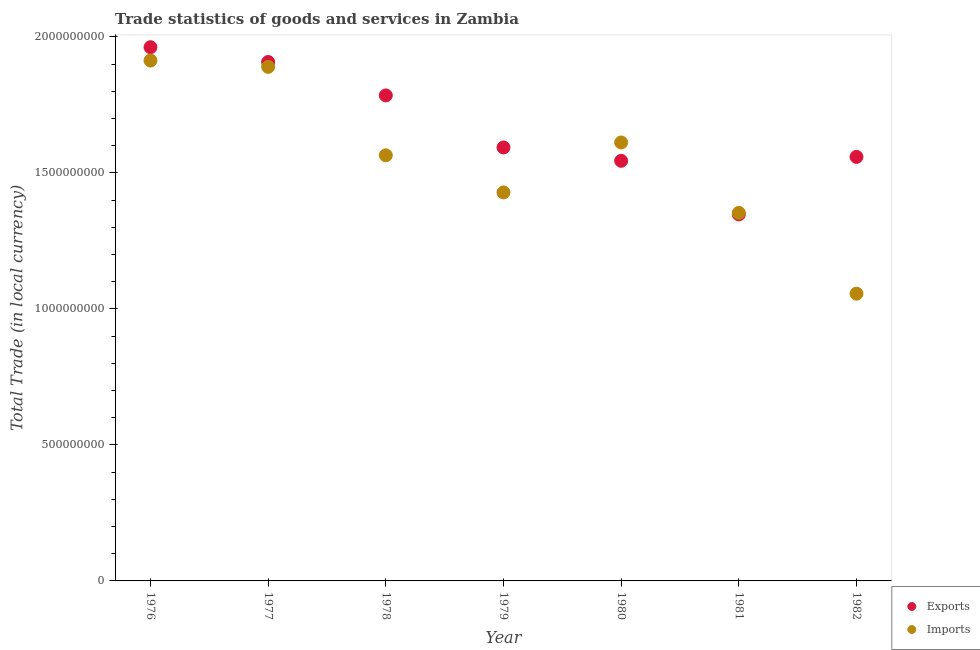Is the number of dotlines equal to the number of legend labels?
Offer a very short reply. Yes. What is the export of goods and services in 1981?
Give a very brief answer. 1.35e+09. Across all years, what is the maximum imports of goods and services?
Provide a succinct answer. 1.91e+09. Across all years, what is the minimum imports of goods and services?
Ensure brevity in your answer.  1.06e+09. In which year was the imports of goods and services maximum?
Your answer should be compact. 1976. In which year was the export of goods and services minimum?
Keep it short and to the point. 1981. What is the total export of goods and services in the graph?
Your answer should be compact. 1.17e+1. What is the difference between the imports of goods and services in 1978 and that in 1981?
Offer a terse response. 2.11e+08. What is the difference between the export of goods and services in 1982 and the imports of goods and services in 1977?
Your response must be concise. -3.31e+08. What is the average export of goods and services per year?
Ensure brevity in your answer.  1.67e+09. In the year 1981, what is the difference between the export of goods and services and imports of goods and services?
Your response must be concise. -5.75e+06. What is the ratio of the export of goods and services in 1980 to that in 1982?
Offer a terse response. 0.99. What is the difference between the highest and the second highest imports of goods and services?
Provide a succinct answer. 2.31e+07. What is the difference between the highest and the lowest imports of goods and services?
Ensure brevity in your answer.  8.57e+08. In how many years, is the export of goods and services greater than the average export of goods and services taken over all years?
Ensure brevity in your answer.  3. Is the sum of the imports of goods and services in 1980 and 1981 greater than the maximum export of goods and services across all years?
Make the answer very short. Yes. Does the imports of goods and services monotonically increase over the years?
Your answer should be compact. No. How many dotlines are there?
Keep it short and to the point. 2. How many years are there in the graph?
Your answer should be compact. 7. Are the values on the major ticks of Y-axis written in scientific E-notation?
Provide a succinct answer. No. Does the graph contain any zero values?
Offer a very short reply. No. Does the graph contain grids?
Offer a very short reply. No. How are the legend labels stacked?
Your answer should be compact. Vertical. What is the title of the graph?
Provide a succinct answer. Trade statistics of goods and services in Zambia. What is the label or title of the Y-axis?
Make the answer very short. Total Trade (in local currency). What is the Total Trade (in local currency) in Exports in 1976?
Make the answer very short. 1.96e+09. What is the Total Trade (in local currency) in Imports in 1976?
Ensure brevity in your answer.  1.91e+09. What is the Total Trade (in local currency) in Exports in 1977?
Ensure brevity in your answer.  1.91e+09. What is the Total Trade (in local currency) of Imports in 1977?
Your answer should be very brief. 1.89e+09. What is the Total Trade (in local currency) of Exports in 1978?
Keep it short and to the point. 1.78e+09. What is the Total Trade (in local currency) in Imports in 1978?
Offer a very short reply. 1.56e+09. What is the Total Trade (in local currency) in Exports in 1979?
Your response must be concise. 1.59e+09. What is the Total Trade (in local currency) in Imports in 1979?
Offer a very short reply. 1.43e+09. What is the Total Trade (in local currency) in Exports in 1980?
Your answer should be compact. 1.54e+09. What is the Total Trade (in local currency) in Imports in 1980?
Provide a short and direct response. 1.61e+09. What is the Total Trade (in local currency) in Exports in 1981?
Provide a succinct answer. 1.35e+09. What is the Total Trade (in local currency) in Imports in 1981?
Provide a succinct answer. 1.35e+09. What is the Total Trade (in local currency) in Exports in 1982?
Offer a very short reply. 1.56e+09. What is the Total Trade (in local currency) in Imports in 1982?
Ensure brevity in your answer.  1.06e+09. Across all years, what is the maximum Total Trade (in local currency) in Exports?
Your response must be concise. 1.96e+09. Across all years, what is the maximum Total Trade (in local currency) in Imports?
Provide a succinct answer. 1.91e+09. Across all years, what is the minimum Total Trade (in local currency) in Exports?
Make the answer very short. 1.35e+09. Across all years, what is the minimum Total Trade (in local currency) in Imports?
Ensure brevity in your answer.  1.06e+09. What is the total Total Trade (in local currency) of Exports in the graph?
Give a very brief answer. 1.17e+1. What is the total Total Trade (in local currency) of Imports in the graph?
Your answer should be very brief. 1.08e+1. What is the difference between the Total Trade (in local currency) in Exports in 1976 and that in 1977?
Offer a terse response. 5.44e+07. What is the difference between the Total Trade (in local currency) in Imports in 1976 and that in 1977?
Provide a succinct answer. 2.31e+07. What is the difference between the Total Trade (in local currency) of Exports in 1976 and that in 1978?
Make the answer very short. 1.77e+08. What is the difference between the Total Trade (in local currency) in Imports in 1976 and that in 1978?
Offer a very short reply. 3.48e+08. What is the difference between the Total Trade (in local currency) in Exports in 1976 and that in 1979?
Keep it short and to the point. 3.69e+08. What is the difference between the Total Trade (in local currency) in Imports in 1976 and that in 1979?
Give a very brief answer. 4.85e+08. What is the difference between the Total Trade (in local currency) of Exports in 1976 and that in 1980?
Your answer should be very brief. 4.18e+08. What is the difference between the Total Trade (in local currency) of Imports in 1976 and that in 1980?
Your answer should be very brief. 3.01e+08. What is the difference between the Total Trade (in local currency) of Exports in 1976 and that in 1981?
Your response must be concise. 6.15e+08. What is the difference between the Total Trade (in local currency) of Imports in 1976 and that in 1981?
Keep it short and to the point. 5.60e+08. What is the difference between the Total Trade (in local currency) of Exports in 1976 and that in 1982?
Keep it short and to the point. 4.03e+08. What is the difference between the Total Trade (in local currency) of Imports in 1976 and that in 1982?
Your answer should be very brief. 8.57e+08. What is the difference between the Total Trade (in local currency) of Exports in 1977 and that in 1978?
Ensure brevity in your answer.  1.23e+08. What is the difference between the Total Trade (in local currency) in Imports in 1977 and that in 1978?
Keep it short and to the point. 3.25e+08. What is the difference between the Total Trade (in local currency) in Exports in 1977 and that in 1979?
Make the answer very short. 3.14e+08. What is the difference between the Total Trade (in local currency) in Imports in 1977 and that in 1979?
Make the answer very short. 4.61e+08. What is the difference between the Total Trade (in local currency) of Exports in 1977 and that in 1980?
Keep it short and to the point. 3.63e+08. What is the difference between the Total Trade (in local currency) of Imports in 1977 and that in 1980?
Ensure brevity in your answer.  2.78e+08. What is the difference between the Total Trade (in local currency) in Exports in 1977 and that in 1981?
Your answer should be very brief. 5.60e+08. What is the difference between the Total Trade (in local currency) of Imports in 1977 and that in 1981?
Ensure brevity in your answer.  5.37e+08. What is the difference between the Total Trade (in local currency) of Exports in 1977 and that in 1982?
Keep it short and to the point. 3.49e+08. What is the difference between the Total Trade (in local currency) in Imports in 1977 and that in 1982?
Provide a short and direct response. 8.34e+08. What is the difference between the Total Trade (in local currency) of Exports in 1978 and that in 1979?
Your answer should be very brief. 1.91e+08. What is the difference between the Total Trade (in local currency) of Imports in 1978 and that in 1979?
Your response must be concise. 1.36e+08. What is the difference between the Total Trade (in local currency) of Exports in 1978 and that in 1980?
Make the answer very short. 2.40e+08. What is the difference between the Total Trade (in local currency) of Imports in 1978 and that in 1980?
Keep it short and to the point. -4.72e+07. What is the difference between the Total Trade (in local currency) of Exports in 1978 and that in 1981?
Provide a succinct answer. 4.37e+08. What is the difference between the Total Trade (in local currency) in Imports in 1978 and that in 1981?
Keep it short and to the point. 2.11e+08. What is the difference between the Total Trade (in local currency) in Exports in 1978 and that in 1982?
Your answer should be very brief. 2.26e+08. What is the difference between the Total Trade (in local currency) in Imports in 1978 and that in 1982?
Give a very brief answer. 5.09e+08. What is the difference between the Total Trade (in local currency) in Exports in 1979 and that in 1980?
Keep it short and to the point. 4.91e+07. What is the difference between the Total Trade (in local currency) of Imports in 1979 and that in 1980?
Keep it short and to the point. -1.84e+08. What is the difference between the Total Trade (in local currency) of Exports in 1979 and that in 1981?
Your response must be concise. 2.46e+08. What is the difference between the Total Trade (in local currency) in Imports in 1979 and that in 1981?
Offer a terse response. 7.51e+07. What is the difference between the Total Trade (in local currency) in Exports in 1979 and that in 1982?
Your answer should be compact. 3.47e+07. What is the difference between the Total Trade (in local currency) in Imports in 1979 and that in 1982?
Your answer should be very brief. 3.72e+08. What is the difference between the Total Trade (in local currency) in Exports in 1980 and that in 1981?
Offer a very short reply. 1.97e+08. What is the difference between the Total Trade (in local currency) in Imports in 1980 and that in 1981?
Ensure brevity in your answer.  2.59e+08. What is the difference between the Total Trade (in local currency) of Exports in 1980 and that in 1982?
Your answer should be compact. -1.44e+07. What is the difference between the Total Trade (in local currency) in Imports in 1980 and that in 1982?
Make the answer very short. 5.56e+08. What is the difference between the Total Trade (in local currency) in Exports in 1981 and that in 1982?
Offer a very short reply. -2.11e+08. What is the difference between the Total Trade (in local currency) in Imports in 1981 and that in 1982?
Your answer should be compact. 2.97e+08. What is the difference between the Total Trade (in local currency) of Exports in 1976 and the Total Trade (in local currency) of Imports in 1977?
Offer a very short reply. 7.23e+07. What is the difference between the Total Trade (in local currency) of Exports in 1976 and the Total Trade (in local currency) of Imports in 1978?
Ensure brevity in your answer.  3.97e+08. What is the difference between the Total Trade (in local currency) in Exports in 1976 and the Total Trade (in local currency) in Imports in 1979?
Provide a succinct answer. 5.34e+08. What is the difference between the Total Trade (in local currency) in Exports in 1976 and the Total Trade (in local currency) in Imports in 1980?
Provide a succinct answer. 3.50e+08. What is the difference between the Total Trade (in local currency) of Exports in 1976 and the Total Trade (in local currency) of Imports in 1981?
Keep it short and to the point. 6.09e+08. What is the difference between the Total Trade (in local currency) in Exports in 1976 and the Total Trade (in local currency) in Imports in 1982?
Keep it short and to the point. 9.06e+08. What is the difference between the Total Trade (in local currency) in Exports in 1977 and the Total Trade (in local currency) in Imports in 1978?
Offer a terse response. 3.43e+08. What is the difference between the Total Trade (in local currency) in Exports in 1977 and the Total Trade (in local currency) in Imports in 1979?
Give a very brief answer. 4.79e+08. What is the difference between the Total Trade (in local currency) of Exports in 1977 and the Total Trade (in local currency) of Imports in 1980?
Your answer should be compact. 2.96e+08. What is the difference between the Total Trade (in local currency) of Exports in 1977 and the Total Trade (in local currency) of Imports in 1981?
Your answer should be compact. 5.54e+08. What is the difference between the Total Trade (in local currency) in Exports in 1977 and the Total Trade (in local currency) in Imports in 1982?
Offer a very short reply. 8.52e+08. What is the difference between the Total Trade (in local currency) in Exports in 1978 and the Total Trade (in local currency) in Imports in 1979?
Ensure brevity in your answer.  3.57e+08. What is the difference between the Total Trade (in local currency) of Exports in 1978 and the Total Trade (in local currency) of Imports in 1980?
Ensure brevity in your answer.  1.73e+08. What is the difference between the Total Trade (in local currency) in Exports in 1978 and the Total Trade (in local currency) in Imports in 1981?
Offer a very short reply. 4.32e+08. What is the difference between the Total Trade (in local currency) in Exports in 1978 and the Total Trade (in local currency) in Imports in 1982?
Offer a terse response. 7.29e+08. What is the difference between the Total Trade (in local currency) in Exports in 1979 and the Total Trade (in local currency) in Imports in 1980?
Offer a very short reply. -1.84e+07. What is the difference between the Total Trade (in local currency) in Exports in 1979 and the Total Trade (in local currency) in Imports in 1981?
Offer a terse response. 2.40e+08. What is the difference between the Total Trade (in local currency) of Exports in 1979 and the Total Trade (in local currency) of Imports in 1982?
Give a very brief answer. 5.37e+08. What is the difference between the Total Trade (in local currency) of Exports in 1980 and the Total Trade (in local currency) of Imports in 1981?
Make the answer very short. 1.91e+08. What is the difference between the Total Trade (in local currency) of Exports in 1980 and the Total Trade (in local currency) of Imports in 1982?
Offer a very short reply. 4.88e+08. What is the difference between the Total Trade (in local currency) in Exports in 1981 and the Total Trade (in local currency) in Imports in 1982?
Keep it short and to the point. 2.91e+08. What is the average Total Trade (in local currency) in Exports per year?
Offer a very short reply. 1.67e+09. What is the average Total Trade (in local currency) in Imports per year?
Your answer should be very brief. 1.55e+09. In the year 1976, what is the difference between the Total Trade (in local currency) in Exports and Total Trade (in local currency) in Imports?
Keep it short and to the point. 4.91e+07. In the year 1977, what is the difference between the Total Trade (in local currency) in Exports and Total Trade (in local currency) in Imports?
Your answer should be very brief. 1.79e+07. In the year 1978, what is the difference between the Total Trade (in local currency) of Exports and Total Trade (in local currency) of Imports?
Make the answer very short. 2.20e+08. In the year 1979, what is the difference between the Total Trade (in local currency) in Exports and Total Trade (in local currency) in Imports?
Your answer should be very brief. 1.65e+08. In the year 1980, what is the difference between the Total Trade (in local currency) in Exports and Total Trade (in local currency) in Imports?
Your answer should be compact. -6.74e+07. In the year 1981, what is the difference between the Total Trade (in local currency) of Exports and Total Trade (in local currency) of Imports?
Your answer should be very brief. -5.75e+06. In the year 1982, what is the difference between the Total Trade (in local currency) of Exports and Total Trade (in local currency) of Imports?
Your answer should be very brief. 5.03e+08. What is the ratio of the Total Trade (in local currency) of Exports in 1976 to that in 1977?
Give a very brief answer. 1.03. What is the ratio of the Total Trade (in local currency) in Imports in 1976 to that in 1977?
Your response must be concise. 1.01. What is the ratio of the Total Trade (in local currency) of Exports in 1976 to that in 1978?
Your response must be concise. 1.1. What is the ratio of the Total Trade (in local currency) of Imports in 1976 to that in 1978?
Keep it short and to the point. 1.22. What is the ratio of the Total Trade (in local currency) in Exports in 1976 to that in 1979?
Provide a succinct answer. 1.23. What is the ratio of the Total Trade (in local currency) in Imports in 1976 to that in 1979?
Give a very brief answer. 1.34. What is the ratio of the Total Trade (in local currency) in Exports in 1976 to that in 1980?
Your answer should be compact. 1.27. What is the ratio of the Total Trade (in local currency) of Imports in 1976 to that in 1980?
Your answer should be compact. 1.19. What is the ratio of the Total Trade (in local currency) in Exports in 1976 to that in 1981?
Offer a very short reply. 1.46. What is the ratio of the Total Trade (in local currency) in Imports in 1976 to that in 1981?
Your answer should be compact. 1.41. What is the ratio of the Total Trade (in local currency) of Exports in 1976 to that in 1982?
Keep it short and to the point. 1.26. What is the ratio of the Total Trade (in local currency) of Imports in 1976 to that in 1982?
Make the answer very short. 1.81. What is the ratio of the Total Trade (in local currency) in Exports in 1977 to that in 1978?
Give a very brief answer. 1.07. What is the ratio of the Total Trade (in local currency) of Imports in 1977 to that in 1978?
Ensure brevity in your answer.  1.21. What is the ratio of the Total Trade (in local currency) in Exports in 1977 to that in 1979?
Offer a very short reply. 1.2. What is the ratio of the Total Trade (in local currency) of Imports in 1977 to that in 1979?
Offer a terse response. 1.32. What is the ratio of the Total Trade (in local currency) of Exports in 1977 to that in 1980?
Your answer should be very brief. 1.24. What is the ratio of the Total Trade (in local currency) of Imports in 1977 to that in 1980?
Your answer should be compact. 1.17. What is the ratio of the Total Trade (in local currency) in Exports in 1977 to that in 1981?
Your answer should be compact. 1.42. What is the ratio of the Total Trade (in local currency) of Imports in 1977 to that in 1981?
Ensure brevity in your answer.  1.4. What is the ratio of the Total Trade (in local currency) of Exports in 1977 to that in 1982?
Your response must be concise. 1.22. What is the ratio of the Total Trade (in local currency) in Imports in 1977 to that in 1982?
Provide a succinct answer. 1.79. What is the ratio of the Total Trade (in local currency) of Exports in 1978 to that in 1979?
Give a very brief answer. 1.12. What is the ratio of the Total Trade (in local currency) of Imports in 1978 to that in 1979?
Your answer should be very brief. 1.1. What is the ratio of the Total Trade (in local currency) of Exports in 1978 to that in 1980?
Make the answer very short. 1.16. What is the ratio of the Total Trade (in local currency) in Imports in 1978 to that in 1980?
Make the answer very short. 0.97. What is the ratio of the Total Trade (in local currency) in Exports in 1978 to that in 1981?
Your answer should be very brief. 1.32. What is the ratio of the Total Trade (in local currency) in Imports in 1978 to that in 1981?
Offer a terse response. 1.16. What is the ratio of the Total Trade (in local currency) of Exports in 1978 to that in 1982?
Give a very brief answer. 1.15. What is the ratio of the Total Trade (in local currency) in Imports in 1978 to that in 1982?
Make the answer very short. 1.48. What is the ratio of the Total Trade (in local currency) of Exports in 1979 to that in 1980?
Keep it short and to the point. 1.03. What is the ratio of the Total Trade (in local currency) in Imports in 1979 to that in 1980?
Your answer should be very brief. 0.89. What is the ratio of the Total Trade (in local currency) in Exports in 1979 to that in 1981?
Provide a short and direct response. 1.18. What is the ratio of the Total Trade (in local currency) of Imports in 1979 to that in 1981?
Keep it short and to the point. 1.06. What is the ratio of the Total Trade (in local currency) in Exports in 1979 to that in 1982?
Your answer should be very brief. 1.02. What is the ratio of the Total Trade (in local currency) of Imports in 1979 to that in 1982?
Make the answer very short. 1.35. What is the ratio of the Total Trade (in local currency) of Exports in 1980 to that in 1981?
Make the answer very short. 1.15. What is the ratio of the Total Trade (in local currency) of Imports in 1980 to that in 1981?
Offer a terse response. 1.19. What is the ratio of the Total Trade (in local currency) of Imports in 1980 to that in 1982?
Make the answer very short. 1.53. What is the ratio of the Total Trade (in local currency) of Exports in 1981 to that in 1982?
Keep it short and to the point. 0.86. What is the ratio of the Total Trade (in local currency) of Imports in 1981 to that in 1982?
Ensure brevity in your answer.  1.28. What is the difference between the highest and the second highest Total Trade (in local currency) in Exports?
Your answer should be compact. 5.44e+07. What is the difference between the highest and the second highest Total Trade (in local currency) of Imports?
Provide a short and direct response. 2.31e+07. What is the difference between the highest and the lowest Total Trade (in local currency) of Exports?
Give a very brief answer. 6.15e+08. What is the difference between the highest and the lowest Total Trade (in local currency) in Imports?
Ensure brevity in your answer.  8.57e+08. 